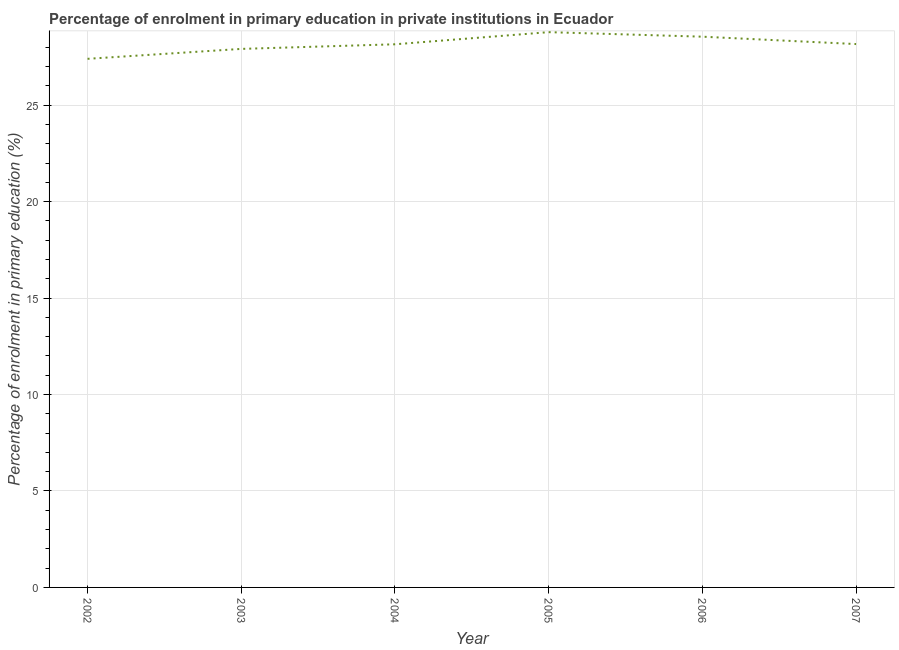What is the enrolment percentage in primary education in 2005?
Your response must be concise. 28.79. Across all years, what is the maximum enrolment percentage in primary education?
Your answer should be compact. 28.79. Across all years, what is the minimum enrolment percentage in primary education?
Offer a terse response. 27.4. What is the sum of the enrolment percentage in primary education?
Give a very brief answer. 168.98. What is the difference between the enrolment percentage in primary education in 2002 and 2004?
Ensure brevity in your answer.  -0.75. What is the average enrolment percentage in primary education per year?
Make the answer very short. 28.16. What is the median enrolment percentage in primary education?
Keep it short and to the point. 28.16. Do a majority of the years between 2003 and 2002 (inclusive) have enrolment percentage in primary education greater than 22 %?
Make the answer very short. No. What is the ratio of the enrolment percentage in primary education in 2002 to that in 2005?
Offer a very short reply. 0.95. Is the difference between the enrolment percentage in primary education in 2003 and 2004 greater than the difference between any two years?
Offer a very short reply. No. What is the difference between the highest and the second highest enrolment percentage in primary education?
Provide a short and direct response. 0.23. What is the difference between the highest and the lowest enrolment percentage in primary education?
Make the answer very short. 1.38. In how many years, is the enrolment percentage in primary education greater than the average enrolment percentage in primary education taken over all years?
Offer a very short reply. 3. Does the enrolment percentage in primary education monotonically increase over the years?
Give a very brief answer. No. Are the values on the major ticks of Y-axis written in scientific E-notation?
Keep it short and to the point. No. What is the title of the graph?
Provide a short and direct response. Percentage of enrolment in primary education in private institutions in Ecuador. What is the label or title of the Y-axis?
Give a very brief answer. Percentage of enrolment in primary education (%). What is the Percentage of enrolment in primary education (%) in 2002?
Offer a very short reply. 27.4. What is the Percentage of enrolment in primary education (%) of 2003?
Your answer should be compact. 27.92. What is the Percentage of enrolment in primary education (%) in 2004?
Provide a succinct answer. 28.16. What is the Percentage of enrolment in primary education (%) of 2005?
Offer a terse response. 28.79. What is the Percentage of enrolment in primary education (%) in 2006?
Your response must be concise. 28.55. What is the Percentage of enrolment in primary education (%) in 2007?
Ensure brevity in your answer.  28.17. What is the difference between the Percentage of enrolment in primary education (%) in 2002 and 2003?
Make the answer very short. -0.51. What is the difference between the Percentage of enrolment in primary education (%) in 2002 and 2004?
Provide a short and direct response. -0.75. What is the difference between the Percentage of enrolment in primary education (%) in 2002 and 2005?
Keep it short and to the point. -1.38. What is the difference between the Percentage of enrolment in primary education (%) in 2002 and 2006?
Your response must be concise. -1.15. What is the difference between the Percentage of enrolment in primary education (%) in 2002 and 2007?
Your answer should be compact. -0.76. What is the difference between the Percentage of enrolment in primary education (%) in 2003 and 2004?
Your answer should be compact. -0.24. What is the difference between the Percentage of enrolment in primary education (%) in 2003 and 2005?
Offer a very short reply. -0.87. What is the difference between the Percentage of enrolment in primary education (%) in 2003 and 2006?
Provide a short and direct response. -0.63. What is the difference between the Percentage of enrolment in primary education (%) in 2003 and 2007?
Your answer should be compact. -0.25. What is the difference between the Percentage of enrolment in primary education (%) in 2004 and 2005?
Give a very brief answer. -0.63. What is the difference between the Percentage of enrolment in primary education (%) in 2004 and 2006?
Offer a very short reply. -0.39. What is the difference between the Percentage of enrolment in primary education (%) in 2004 and 2007?
Provide a succinct answer. -0.01. What is the difference between the Percentage of enrolment in primary education (%) in 2005 and 2006?
Offer a very short reply. 0.23. What is the difference between the Percentage of enrolment in primary education (%) in 2005 and 2007?
Your response must be concise. 0.62. What is the difference between the Percentage of enrolment in primary education (%) in 2006 and 2007?
Provide a short and direct response. 0.38. What is the ratio of the Percentage of enrolment in primary education (%) in 2002 to that in 2003?
Your answer should be compact. 0.98. What is the ratio of the Percentage of enrolment in primary education (%) in 2002 to that in 2007?
Offer a very short reply. 0.97. What is the ratio of the Percentage of enrolment in primary education (%) in 2003 to that in 2004?
Your answer should be very brief. 0.99. What is the ratio of the Percentage of enrolment in primary education (%) in 2003 to that in 2005?
Your answer should be compact. 0.97. What is the ratio of the Percentage of enrolment in primary education (%) in 2004 to that in 2005?
Offer a terse response. 0.98. What is the ratio of the Percentage of enrolment in primary education (%) in 2004 to that in 2007?
Your answer should be compact. 1. What is the ratio of the Percentage of enrolment in primary education (%) in 2005 to that in 2006?
Offer a terse response. 1.01. What is the ratio of the Percentage of enrolment in primary education (%) in 2006 to that in 2007?
Make the answer very short. 1.01. 